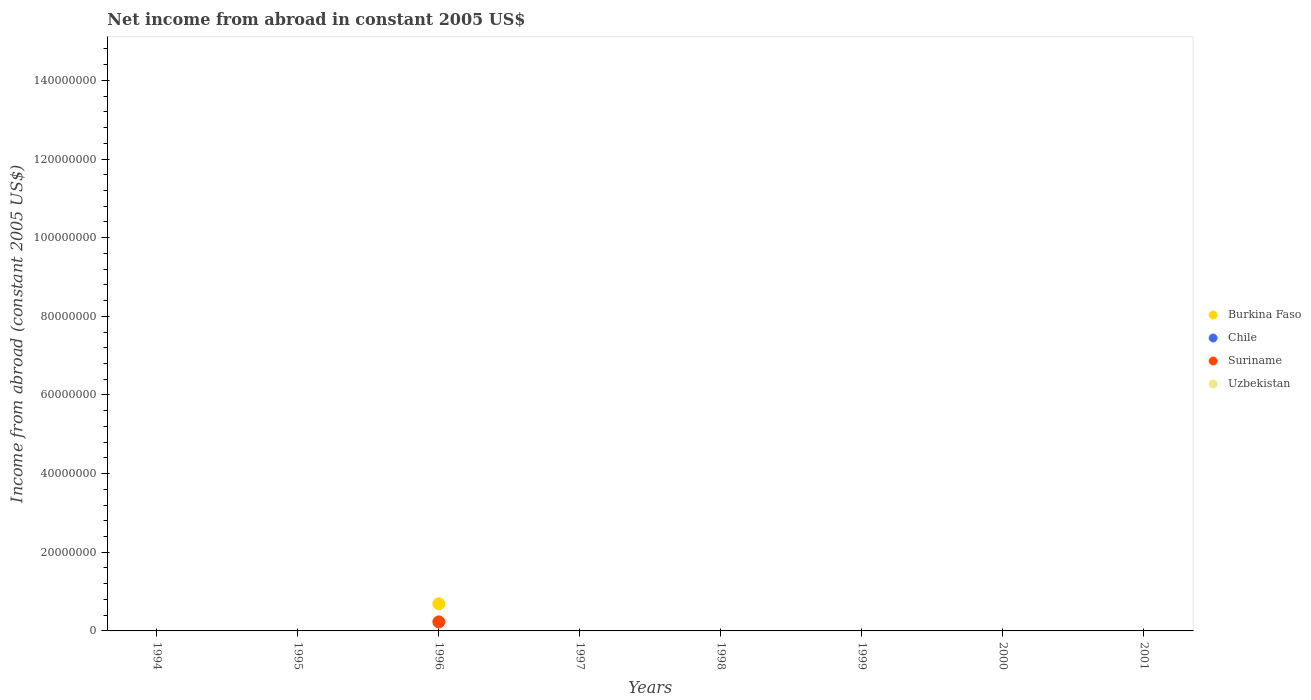What is the net income from abroad in Burkina Faso in 1996?
Your response must be concise. 6.90e+06. Across all years, what is the maximum net income from abroad in Suriname?
Ensure brevity in your answer.  2.30e+06. Across all years, what is the minimum net income from abroad in Chile?
Give a very brief answer. 0. What is the total net income from abroad in Burkina Faso in the graph?
Make the answer very short. 6.90e+06. What is the difference between the net income from abroad in Uzbekistan in 1999 and the net income from abroad in Suriname in 1996?
Give a very brief answer. -2.30e+06. In the year 1996, what is the difference between the net income from abroad in Suriname and net income from abroad in Burkina Faso?
Keep it short and to the point. -4.60e+06. In how many years, is the net income from abroad in Uzbekistan greater than 108000000 US$?
Offer a very short reply. 0. What is the difference between the highest and the lowest net income from abroad in Burkina Faso?
Your response must be concise. 6.90e+06. Is it the case that in every year, the sum of the net income from abroad in Uzbekistan and net income from abroad in Chile  is greater than the sum of net income from abroad in Burkina Faso and net income from abroad in Suriname?
Your answer should be very brief. No. Is the net income from abroad in Chile strictly less than the net income from abroad in Suriname over the years?
Offer a very short reply. Yes. How many dotlines are there?
Your answer should be very brief. 2. What is the difference between two consecutive major ticks on the Y-axis?
Your answer should be compact. 2.00e+07. Are the values on the major ticks of Y-axis written in scientific E-notation?
Offer a terse response. No. Does the graph contain any zero values?
Make the answer very short. Yes. Where does the legend appear in the graph?
Provide a succinct answer. Center right. How are the legend labels stacked?
Your response must be concise. Vertical. What is the title of the graph?
Ensure brevity in your answer.  Net income from abroad in constant 2005 US$. What is the label or title of the X-axis?
Your answer should be very brief. Years. What is the label or title of the Y-axis?
Your response must be concise. Income from abroad (constant 2005 US$). What is the Income from abroad (constant 2005 US$) in Burkina Faso in 1995?
Offer a very short reply. 0. What is the Income from abroad (constant 2005 US$) of Chile in 1995?
Your answer should be compact. 0. What is the Income from abroad (constant 2005 US$) in Uzbekistan in 1995?
Offer a terse response. 0. What is the Income from abroad (constant 2005 US$) of Burkina Faso in 1996?
Keep it short and to the point. 6.90e+06. What is the Income from abroad (constant 2005 US$) of Suriname in 1996?
Your response must be concise. 2.30e+06. What is the Income from abroad (constant 2005 US$) of Uzbekistan in 1996?
Your answer should be compact. 0. What is the Income from abroad (constant 2005 US$) of Chile in 1997?
Provide a short and direct response. 0. What is the Income from abroad (constant 2005 US$) in Suriname in 1997?
Your response must be concise. 0. What is the Income from abroad (constant 2005 US$) in Chile in 1998?
Offer a terse response. 0. What is the Income from abroad (constant 2005 US$) in Suriname in 1998?
Provide a short and direct response. 0. What is the Income from abroad (constant 2005 US$) in Uzbekistan in 1998?
Give a very brief answer. 0. What is the Income from abroad (constant 2005 US$) of Suriname in 1999?
Provide a short and direct response. 0. What is the Income from abroad (constant 2005 US$) in Uzbekistan in 1999?
Your answer should be very brief. 0. What is the Income from abroad (constant 2005 US$) of Suriname in 2000?
Give a very brief answer. 0. What is the Income from abroad (constant 2005 US$) in Uzbekistan in 2000?
Offer a terse response. 0. What is the Income from abroad (constant 2005 US$) in Burkina Faso in 2001?
Keep it short and to the point. 0. What is the Income from abroad (constant 2005 US$) of Suriname in 2001?
Provide a short and direct response. 0. What is the Income from abroad (constant 2005 US$) in Uzbekistan in 2001?
Provide a short and direct response. 0. Across all years, what is the maximum Income from abroad (constant 2005 US$) of Burkina Faso?
Offer a very short reply. 6.90e+06. Across all years, what is the maximum Income from abroad (constant 2005 US$) in Suriname?
Your answer should be very brief. 2.30e+06. What is the total Income from abroad (constant 2005 US$) in Burkina Faso in the graph?
Provide a short and direct response. 6.90e+06. What is the total Income from abroad (constant 2005 US$) of Suriname in the graph?
Keep it short and to the point. 2.30e+06. What is the average Income from abroad (constant 2005 US$) in Burkina Faso per year?
Your answer should be compact. 8.62e+05. What is the average Income from abroad (constant 2005 US$) in Chile per year?
Offer a terse response. 0. What is the average Income from abroad (constant 2005 US$) in Suriname per year?
Offer a terse response. 2.88e+05. What is the average Income from abroad (constant 2005 US$) in Uzbekistan per year?
Make the answer very short. 0. In the year 1996, what is the difference between the Income from abroad (constant 2005 US$) of Burkina Faso and Income from abroad (constant 2005 US$) of Suriname?
Give a very brief answer. 4.60e+06. What is the difference between the highest and the lowest Income from abroad (constant 2005 US$) of Burkina Faso?
Provide a succinct answer. 6.90e+06. What is the difference between the highest and the lowest Income from abroad (constant 2005 US$) in Suriname?
Provide a succinct answer. 2.30e+06. 